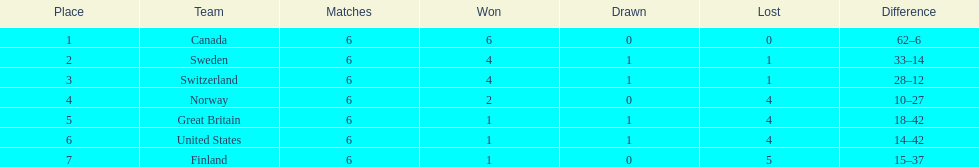What team placed after canada? Sweden. 